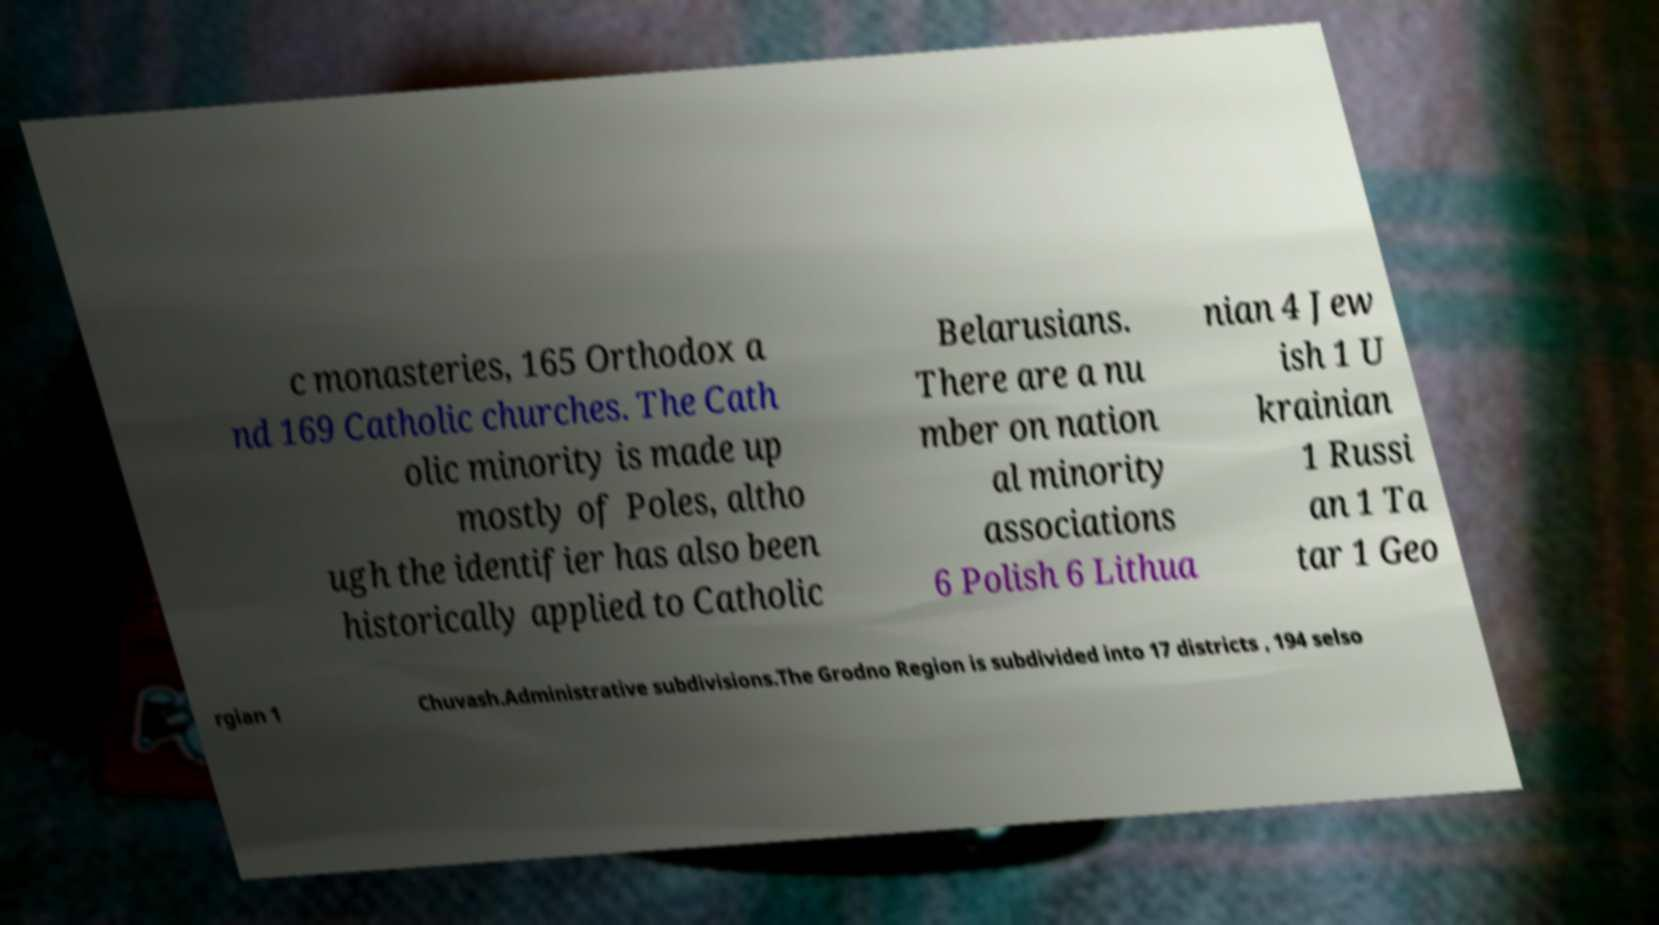I need the written content from this picture converted into text. Can you do that? c monasteries, 165 Orthodox a nd 169 Catholic churches. The Cath olic minority is made up mostly of Poles, altho ugh the identifier has also been historically applied to Catholic Belarusians. There are a nu mber on nation al minority associations 6 Polish 6 Lithua nian 4 Jew ish 1 U krainian 1 Russi an 1 Ta tar 1 Geo rgian 1 Chuvash.Administrative subdivisions.The Grodno Region is subdivided into 17 districts , 194 selso 